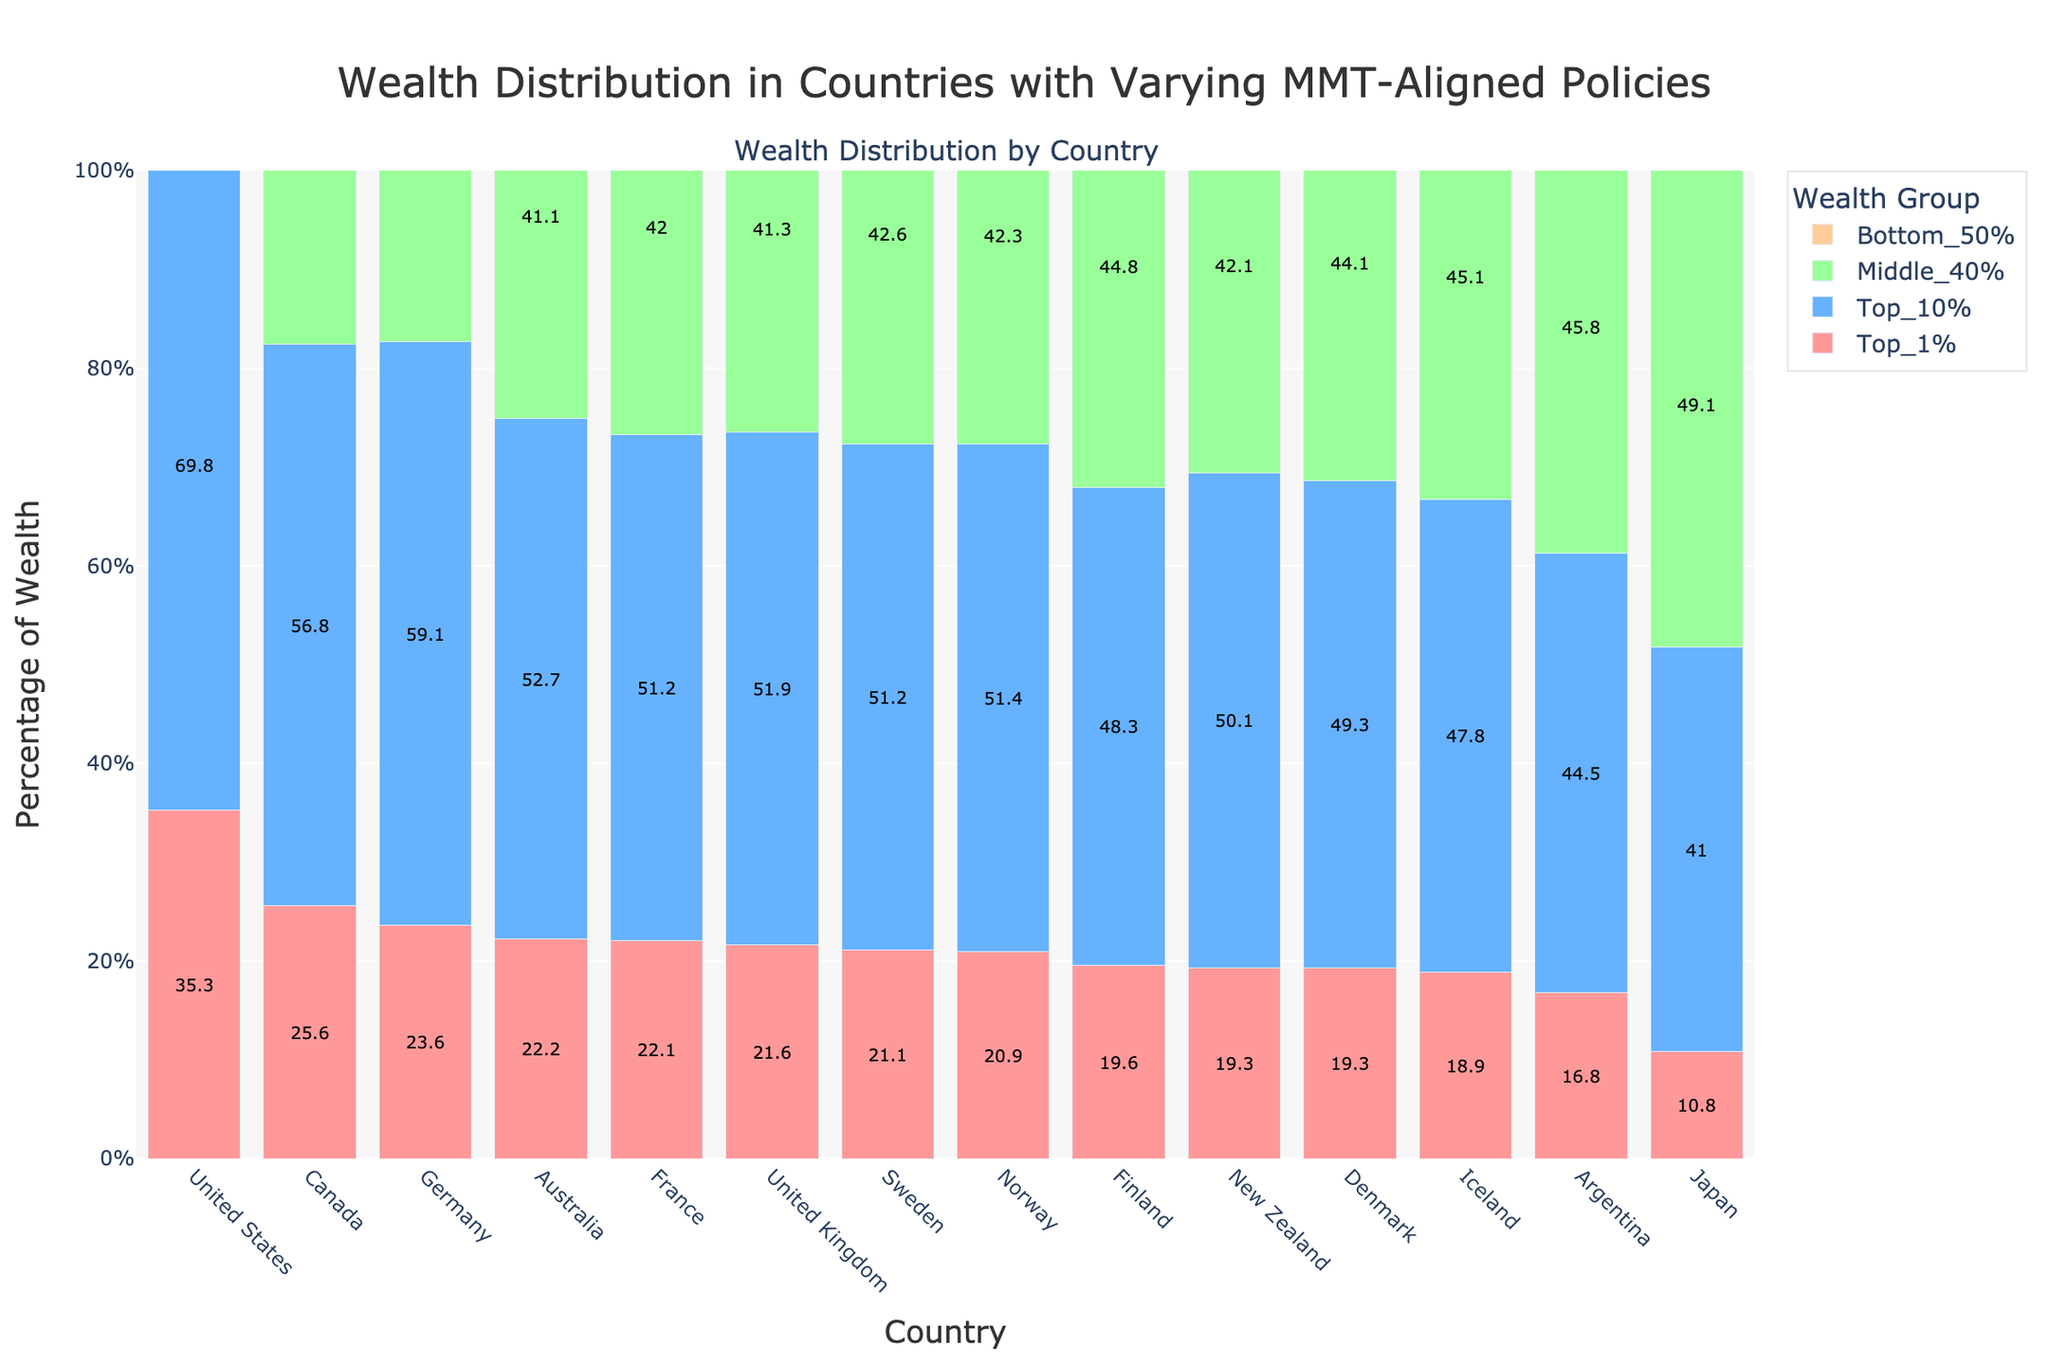What's the total percentage of wealth held by the Top 10% and Bottom 50% in Canada? To find the total percentage of wealth held by the Top 10% and Bottom 50% in Canada, we add the corresponding percentages: Top 10% (56.8%) + Bottom 50% (5.4%) = 62.2%.
Answer: 62.2% Which country shows the lowest percentage of wealth held by the Bottom 50%? To determine which country has the lowest percentage of wealth held by the Bottom 50%, check the Bottom 50% column and find the minimum value, which is the United States at 2.0%.
Answer: United States What’s the percentage difference between the Top 1% and Middle 40% in Germany? Subtract the percentage of wealth held by the Middle 40% from that of the Top 1% in Germany: 23.6% (Top 1%) - 36.9% (Middle 40%) = -13.3%.
Answer: -13.3% In which country do the Top 1% hold a greater percentage of wealth compared to the Top 10%? Compare the percentages of the Top 1% and Top 10% across all countries. There is no country where the Top 1% hold a greater percentage than the Top 10% as per the given data.
Answer: None Which country has the most balanced distribution of wealth where each group holds relatively similar percentages? Analyze the wealth distribution for each country. Japan has a relatively balanced distribution with Top 1% (10.8%), Top 10% (41.0%), Middle 40% (49.1%), Bottom 50% (9.9%).
Answer: Japan Identify the country with the highest disparity between the Top 1% and Bottom 50%. Calculate the difference between the Top 1% and Bottom 50% in each country. The United States shows the highest disparity with 35.3% (Top 1%) - 2.0% (Bottom 50%) = 33.3%.
Answer: United States How much more wealth does the Top 10% hold compared to the Bottom 50% in New Zealand? Subtract the wealth percentage of the Bottom 50% from that of the Top 10% in New Zealand: 50.1% (Top 10%) - 7.8% (Bottom 50%) = 42.3%.
Answer: 42.3% What is the average percentage of wealth held by the Middle 40% across all countries with High policy alignment? Sum the percentages of the Middle 40% in High policy alignment countries and divide by the number of such countries: (49.1% + 45.8% + 42.3% + 42.6% + 44.1% + 44.8% + 45.1%) / 7 ≈ 44.0%.
Answer: 44.0% Which color represents the wealth held by the Middle 40%? The colors used are specified in the code. The order of colors is applied by index, with the Middle 40% being the third category, so it corresponds to the green color.
Answer: Green 